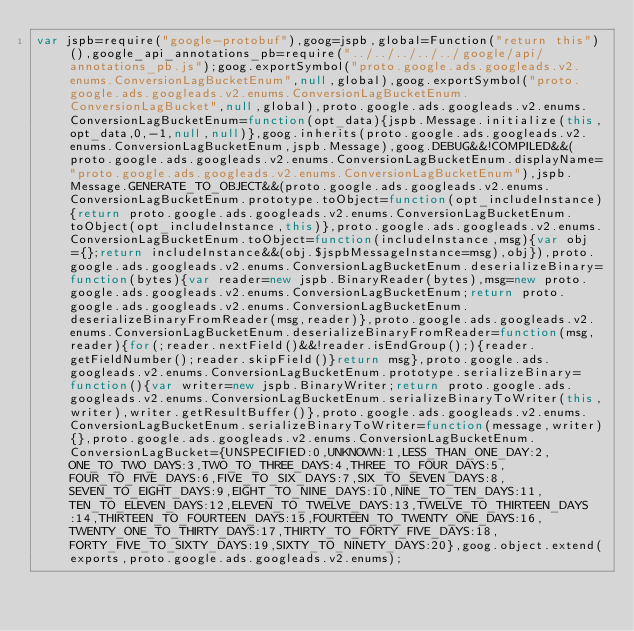Convert code to text. <code><loc_0><loc_0><loc_500><loc_500><_JavaScript_>var jspb=require("google-protobuf"),goog=jspb,global=Function("return this")(),google_api_annotations_pb=require("../../../../../google/api/annotations_pb.js");goog.exportSymbol("proto.google.ads.googleads.v2.enums.ConversionLagBucketEnum",null,global),goog.exportSymbol("proto.google.ads.googleads.v2.enums.ConversionLagBucketEnum.ConversionLagBucket",null,global),proto.google.ads.googleads.v2.enums.ConversionLagBucketEnum=function(opt_data){jspb.Message.initialize(this,opt_data,0,-1,null,null)},goog.inherits(proto.google.ads.googleads.v2.enums.ConversionLagBucketEnum,jspb.Message),goog.DEBUG&&!COMPILED&&(proto.google.ads.googleads.v2.enums.ConversionLagBucketEnum.displayName="proto.google.ads.googleads.v2.enums.ConversionLagBucketEnum"),jspb.Message.GENERATE_TO_OBJECT&&(proto.google.ads.googleads.v2.enums.ConversionLagBucketEnum.prototype.toObject=function(opt_includeInstance){return proto.google.ads.googleads.v2.enums.ConversionLagBucketEnum.toObject(opt_includeInstance,this)},proto.google.ads.googleads.v2.enums.ConversionLagBucketEnum.toObject=function(includeInstance,msg){var obj={};return includeInstance&&(obj.$jspbMessageInstance=msg),obj}),proto.google.ads.googleads.v2.enums.ConversionLagBucketEnum.deserializeBinary=function(bytes){var reader=new jspb.BinaryReader(bytes),msg=new proto.google.ads.googleads.v2.enums.ConversionLagBucketEnum;return proto.google.ads.googleads.v2.enums.ConversionLagBucketEnum.deserializeBinaryFromReader(msg,reader)},proto.google.ads.googleads.v2.enums.ConversionLagBucketEnum.deserializeBinaryFromReader=function(msg,reader){for(;reader.nextField()&&!reader.isEndGroup();){reader.getFieldNumber();reader.skipField()}return msg},proto.google.ads.googleads.v2.enums.ConversionLagBucketEnum.prototype.serializeBinary=function(){var writer=new jspb.BinaryWriter;return proto.google.ads.googleads.v2.enums.ConversionLagBucketEnum.serializeBinaryToWriter(this,writer),writer.getResultBuffer()},proto.google.ads.googleads.v2.enums.ConversionLagBucketEnum.serializeBinaryToWriter=function(message,writer){},proto.google.ads.googleads.v2.enums.ConversionLagBucketEnum.ConversionLagBucket={UNSPECIFIED:0,UNKNOWN:1,LESS_THAN_ONE_DAY:2,ONE_TO_TWO_DAYS:3,TWO_TO_THREE_DAYS:4,THREE_TO_FOUR_DAYS:5,FOUR_TO_FIVE_DAYS:6,FIVE_TO_SIX_DAYS:7,SIX_TO_SEVEN_DAYS:8,SEVEN_TO_EIGHT_DAYS:9,EIGHT_TO_NINE_DAYS:10,NINE_TO_TEN_DAYS:11,TEN_TO_ELEVEN_DAYS:12,ELEVEN_TO_TWELVE_DAYS:13,TWELVE_TO_THIRTEEN_DAYS:14,THIRTEEN_TO_FOURTEEN_DAYS:15,FOURTEEN_TO_TWENTY_ONE_DAYS:16,TWENTY_ONE_TO_THIRTY_DAYS:17,THIRTY_TO_FORTY_FIVE_DAYS:18,FORTY_FIVE_TO_SIXTY_DAYS:19,SIXTY_TO_NINETY_DAYS:20},goog.object.extend(exports,proto.google.ads.googleads.v2.enums);</code> 